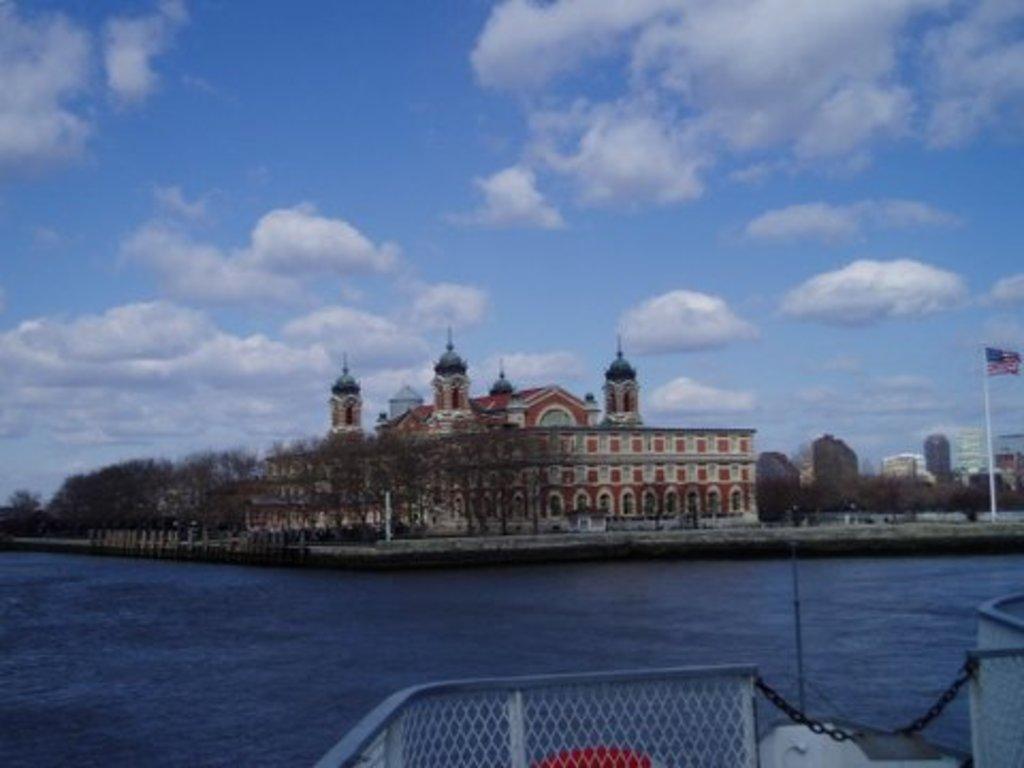How would you summarize this image in a sentence or two? In the center of the image we can see trees and building. At the bottom of the image we can see deck and water. In the background we can see buildings, sky and clouds. 